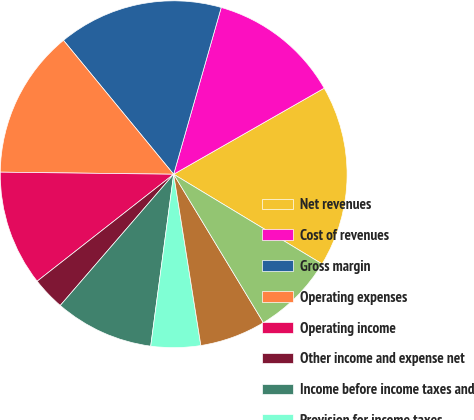Convert chart. <chart><loc_0><loc_0><loc_500><loc_500><pie_chart><fcel>Net revenues<fcel>Cost of revenues<fcel>Gross margin<fcel>Operating expenses<fcel>Operating income<fcel>Other income and expense net<fcel>Income before income taxes and<fcel>Provision for income taxes<fcel>Consolidated net income<fcel>Net income attributable to<nl><fcel>16.92%<fcel>12.31%<fcel>15.38%<fcel>13.85%<fcel>10.77%<fcel>3.08%<fcel>9.23%<fcel>4.62%<fcel>6.15%<fcel>7.69%<nl></chart> 